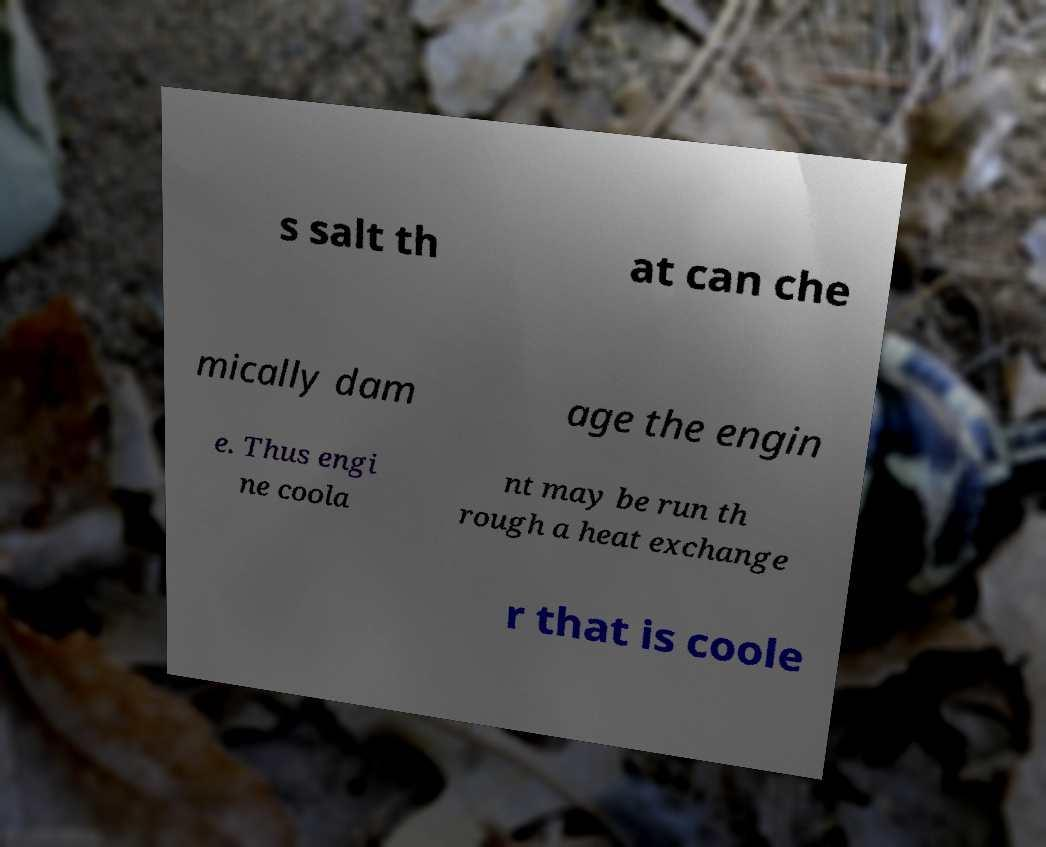Could you assist in decoding the text presented in this image and type it out clearly? s salt th at can che mically dam age the engin e. Thus engi ne coola nt may be run th rough a heat exchange r that is coole 